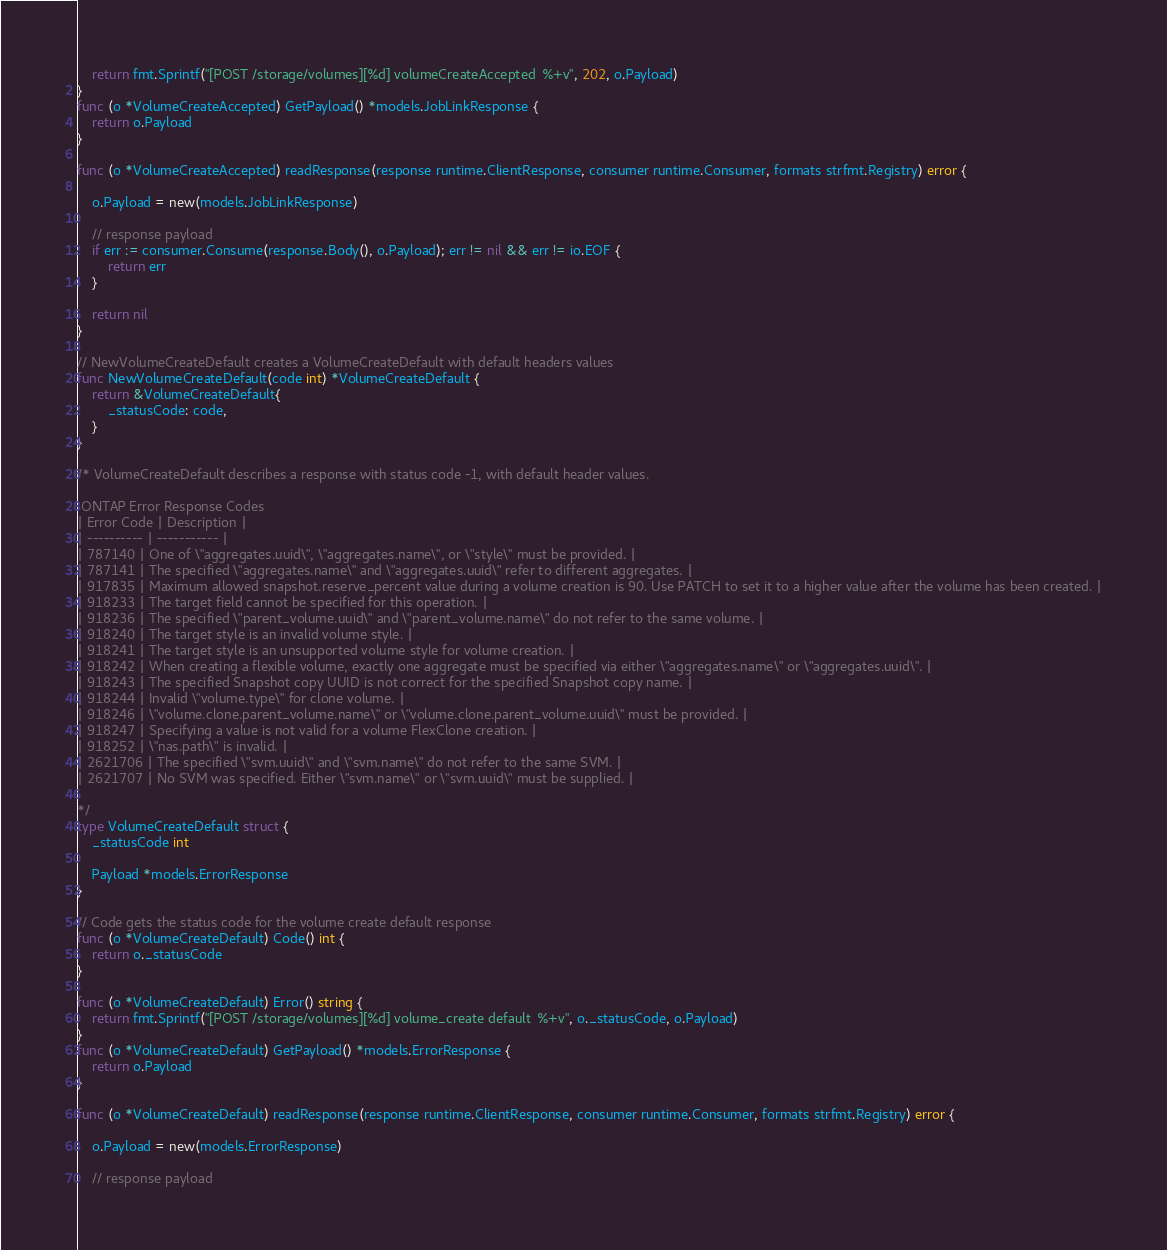Convert code to text. <code><loc_0><loc_0><loc_500><loc_500><_Go_>	return fmt.Sprintf("[POST /storage/volumes][%d] volumeCreateAccepted  %+v", 202, o.Payload)
}
func (o *VolumeCreateAccepted) GetPayload() *models.JobLinkResponse {
	return o.Payload
}

func (o *VolumeCreateAccepted) readResponse(response runtime.ClientResponse, consumer runtime.Consumer, formats strfmt.Registry) error {

	o.Payload = new(models.JobLinkResponse)

	// response payload
	if err := consumer.Consume(response.Body(), o.Payload); err != nil && err != io.EOF {
		return err
	}

	return nil
}

// NewVolumeCreateDefault creates a VolumeCreateDefault with default headers values
func NewVolumeCreateDefault(code int) *VolumeCreateDefault {
	return &VolumeCreateDefault{
		_statusCode: code,
	}
}

/* VolumeCreateDefault describes a response with status code -1, with default header values.

 ONTAP Error Response Codes
| Error Code | Description |
| ---------- | ----------- |
| 787140 | One of \"aggregates.uuid\", \"aggregates.name\", or \"style\" must be provided. |
| 787141 | The specified \"aggregates.name\" and \"aggregates.uuid\" refer to different aggregates. |
| 917835 | Maximum allowed snapshot.reserve_percent value during a volume creation is 90. Use PATCH to set it to a higher value after the volume has been created. |
| 918233 | The target field cannot be specified for this operation. |
| 918236 | The specified \"parent_volume.uuid\" and \"parent_volume.name\" do not refer to the same volume. |
| 918240 | The target style is an invalid volume style. |
| 918241 | The target style is an unsupported volume style for volume creation. |
| 918242 | When creating a flexible volume, exactly one aggregate must be specified via either \"aggregates.name\" or \"aggregates.uuid\". |
| 918243 | The specified Snapshot copy UUID is not correct for the specified Snapshot copy name. |
| 918244 | Invalid \"volume.type\" for clone volume. |
| 918246 | \"volume.clone.parent_volume.name\" or \"volume.clone.parent_volume.uuid\" must be provided. |
| 918247 | Specifying a value is not valid for a volume FlexClone creation. |
| 918252 | \"nas.path\" is invalid. |
| 2621706 | The specified \"svm.uuid\" and \"svm.name\" do not refer to the same SVM. |
| 2621707 | No SVM was specified. Either \"svm.name\" or \"svm.uuid\" must be supplied. |

*/
type VolumeCreateDefault struct {
	_statusCode int

	Payload *models.ErrorResponse
}

// Code gets the status code for the volume create default response
func (o *VolumeCreateDefault) Code() int {
	return o._statusCode
}

func (o *VolumeCreateDefault) Error() string {
	return fmt.Sprintf("[POST /storage/volumes][%d] volume_create default  %+v", o._statusCode, o.Payload)
}
func (o *VolumeCreateDefault) GetPayload() *models.ErrorResponse {
	return o.Payload
}

func (o *VolumeCreateDefault) readResponse(response runtime.ClientResponse, consumer runtime.Consumer, formats strfmt.Registry) error {

	o.Payload = new(models.ErrorResponse)

	// response payload</code> 